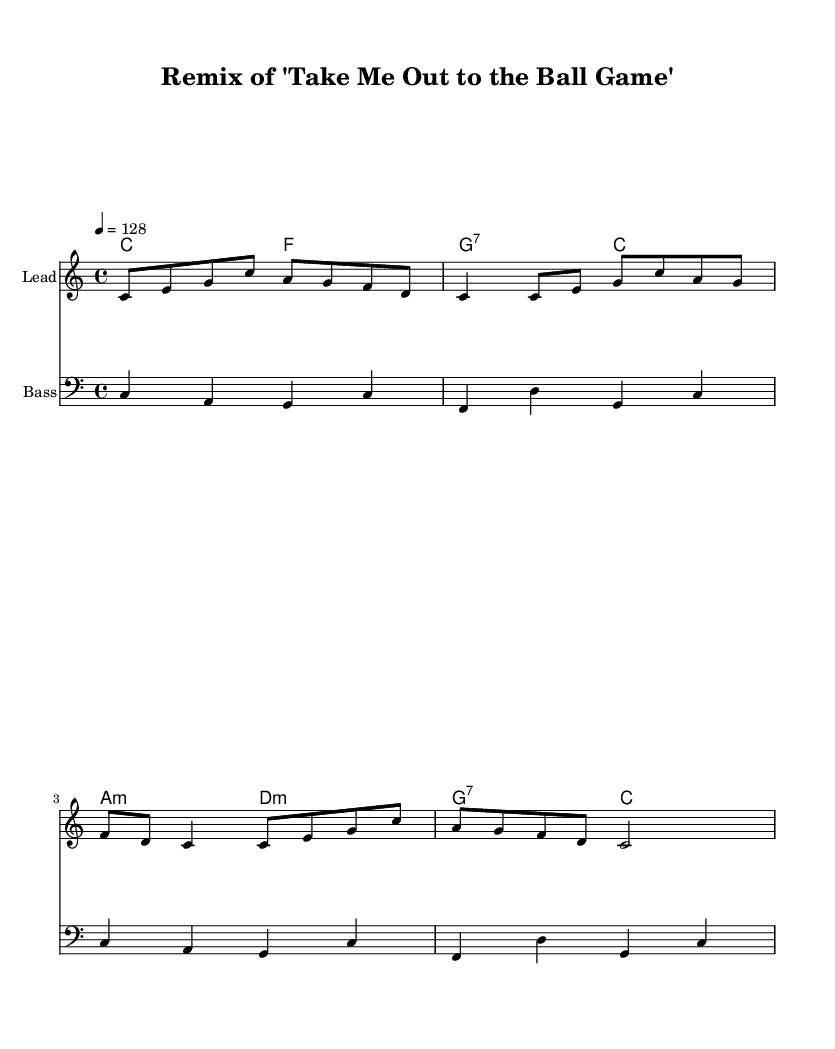What is the key signature of this music? The key signature is indicated at the beginning of the staff, showing no sharps or flats, which signifies C major.
Answer: C major What is the time signature of this music? The time signature is located at the start of the sheet music and is noted as 4/4, meaning there are four beats per measure.
Answer: 4/4 What is the tempo marking of this piece? The tempo marking is found at the beginning of the score, where it shows eighth note equals 128 beats per minute, indicating a lively speed.
Answer: 128 What chords are used in the second measure of the harmonies? The second measure of the harmonies shows the chord symbols, which indicate it uses G dominant seventh chord transitioning to C major.
Answer: G7, C What is the clef used for the bass part? The bass part indicates a specific clef at the beginning, which is the bass clef, typically used for lower-pitched instruments.
Answer: Bass clef Which instrument is assigned to the lead staff? The lead staff specifies the instrument used for the melody by stating "lead 2 (sawtooth)" as the MIDI instrument designation.
Answer: Lead 2 (sawtooth) 